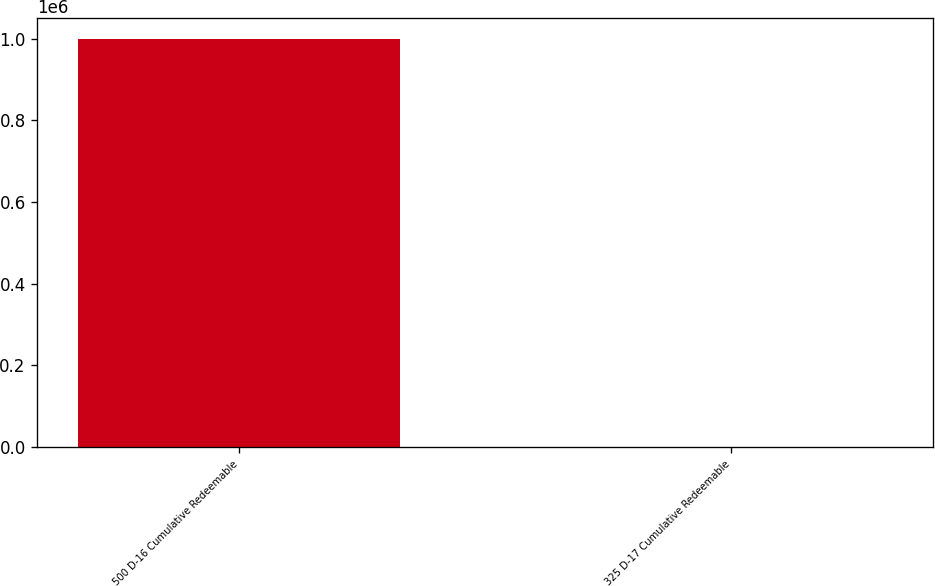<chart> <loc_0><loc_0><loc_500><loc_500><bar_chart><fcel>500 D-16 Cumulative Redeemable<fcel>325 D-17 Cumulative Redeemable<nl><fcel>1e+06<fcel>25<nl></chart> 